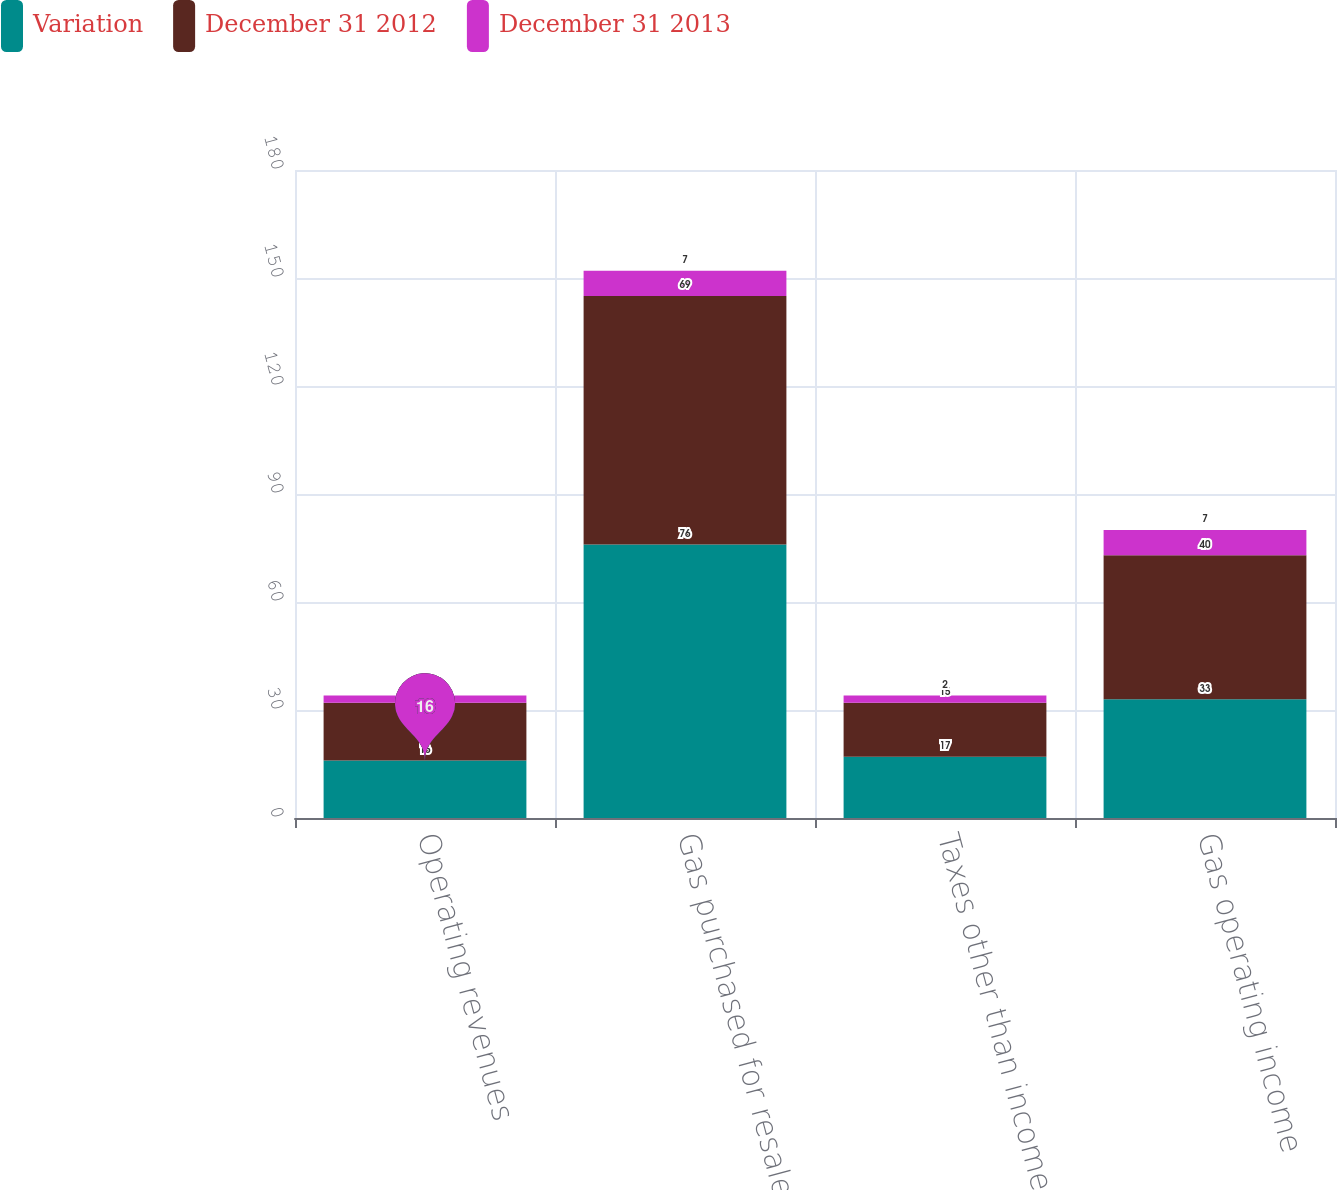Convert chart to OTSL. <chart><loc_0><loc_0><loc_500><loc_500><stacked_bar_chart><ecel><fcel>Operating revenues<fcel>Gas purchased for resale<fcel>Taxes other than income taxes<fcel>Gas operating income<nl><fcel>Variation<fcel>16<fcel>76<fcel>17<fcel>33<nl><fcel>December 31 2012<fcel>16<fcel>69<fcel>15<fcel>40<nl><fcel>December 31 2013<fcel>2<fcel>7<fcel>2<fcel>7<nl></chart> 